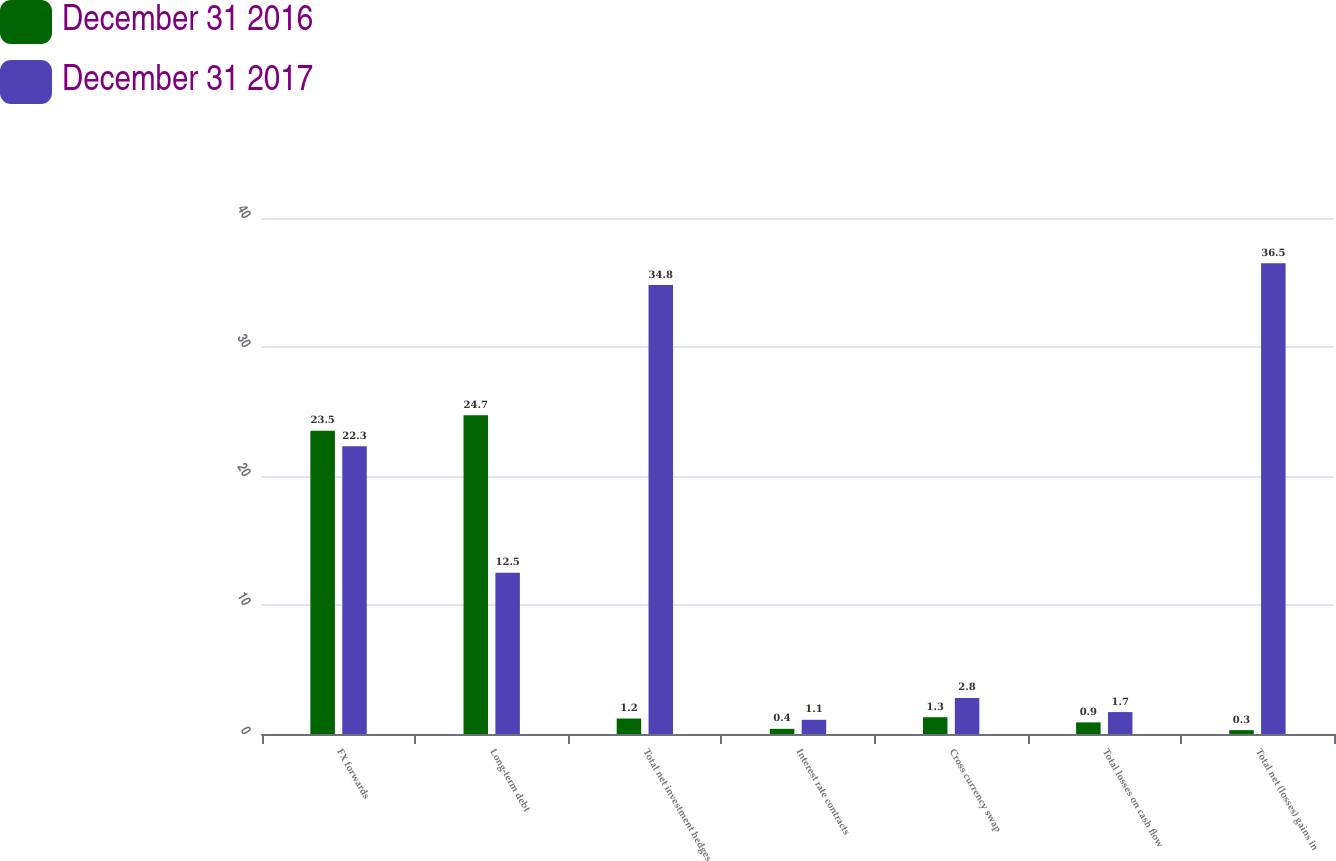Convert chart. <chart><loc_0><loc_0><loc_500><loc_500><stacked_bar_chart><ecel><fcel>FX forwards<fcel>Long-term debt<fcel>Total net investment hedges<fcel>Interest rate contracts<fcel>Cross currency swap<fcel>Total losses on cash flow<fcel>Total net (losses) gains in<nl><fcel>December 31 2016<fcel>23.5<fcel>24.7<fcel>1.2<fcel>0.4<fcel>1.3<fcel>0.9<fcel>0.3<nl><fcel>December 31 2017<fcel>22.3<fcel>12.5<fcel>34.8<fcel>1.1<fcel>2.8<fcel>1.7<fcel>36.5<nl></chart> 